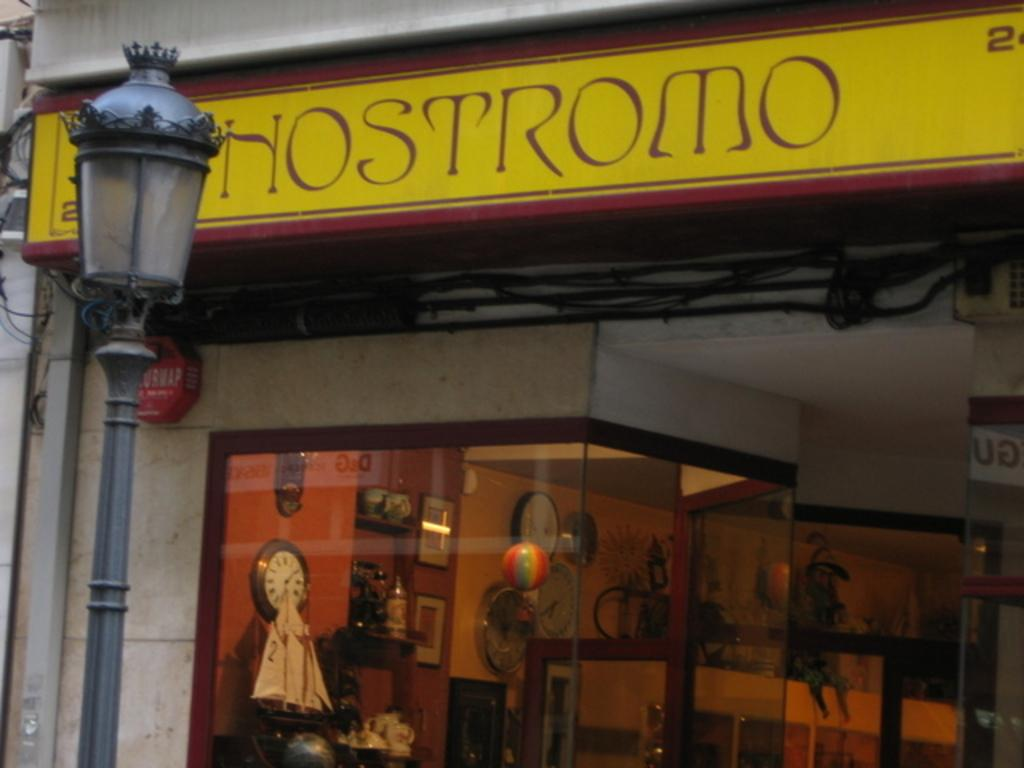<image>
Render a clear and concise summary of the photo. a store front with the words Hostromo over the windows 